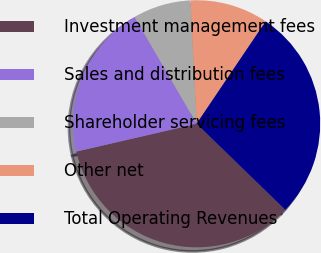Convert chart. <chart><loc_0><loc_0><loc_500><loc_500><pie_chart><fcel>Investment management fees<fcel>Sales and distribution fees<fcel>Shareholder servicing fees<fcel>Other net<fcel>Total Operating Revenues<nl><fcel>34.13%<fcel>20.23%<fcel>7.59%<fcel>10.24%<fcel>27.81%<nl></chart> 